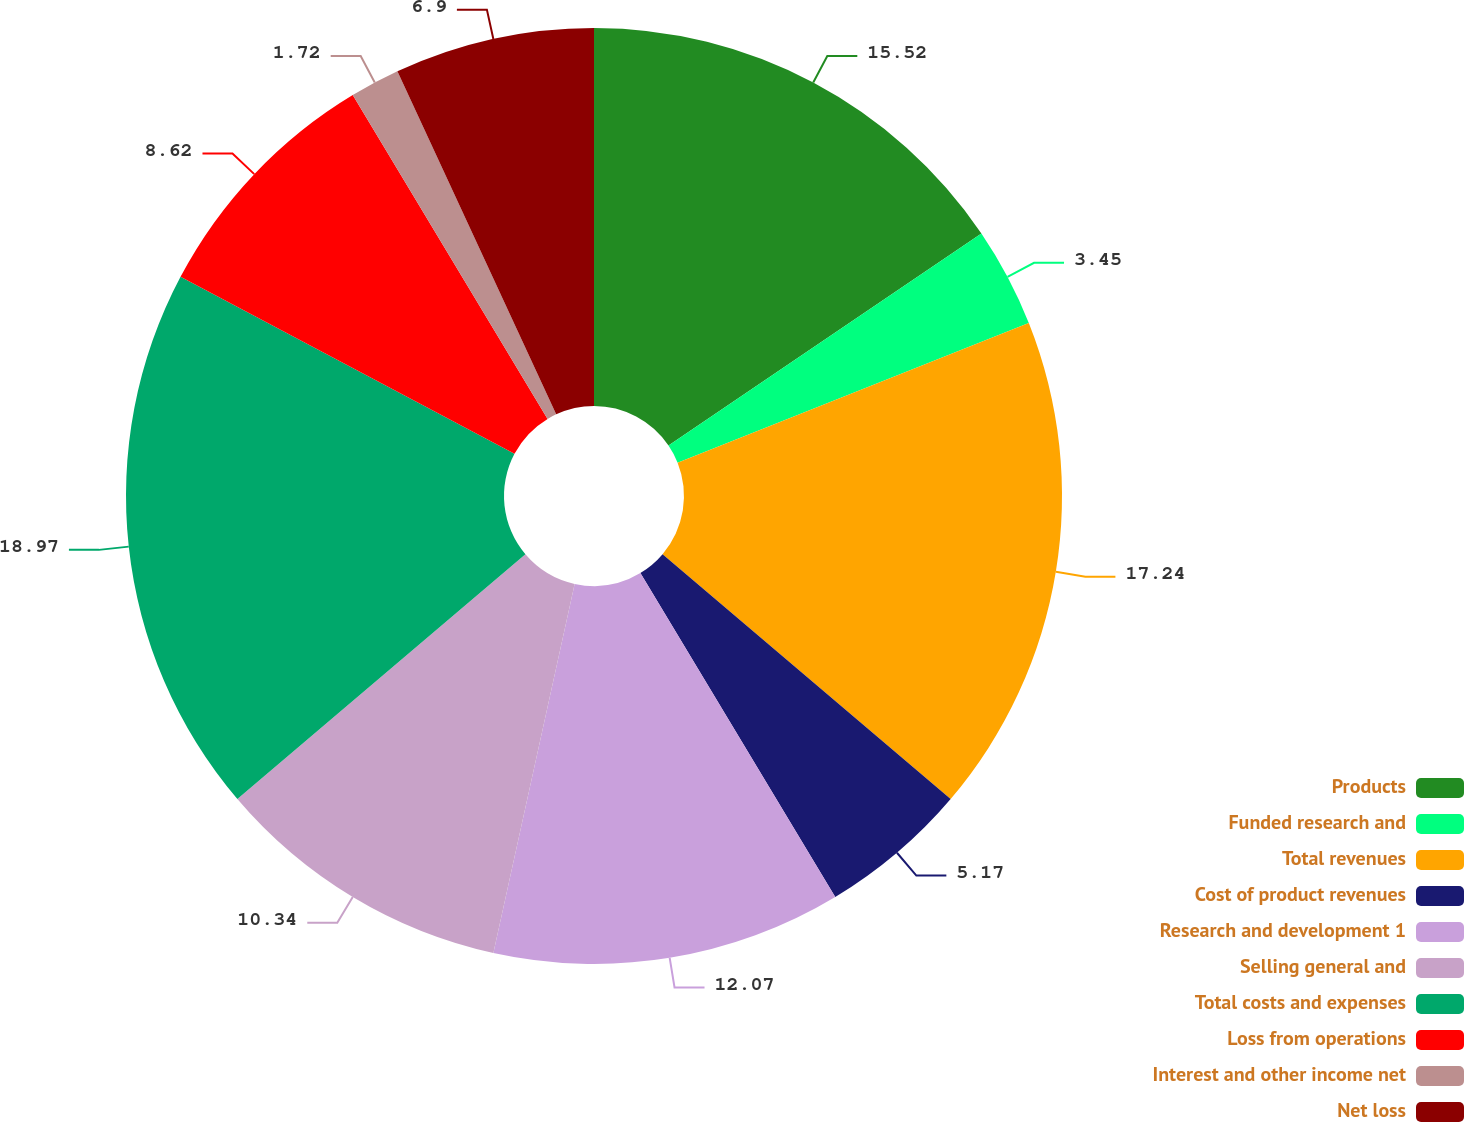Convert chart to OTSL. <chart><loc_0><loc_0><loc_500><loc_500><pie_chart><fcel>Products<fcel>Funded research and<fcel>Total revenues<fcel>Cost of product revenues<fcel>Research and development 1<fcel>Selling general and<fcel>Total costs and expenses<fcel>Loss from operations<fcel>Interest and other income net<fcel>Net loss<nl><fcel>15.52%<fcel>3.45%<fcel>17.24%<fcel>5.17%<fcel>12.07%<fcel>10.34%<fcel>18.97%<fcel>8.62%<fcel>1.72%<fcel>6.9%<nl></chart> 